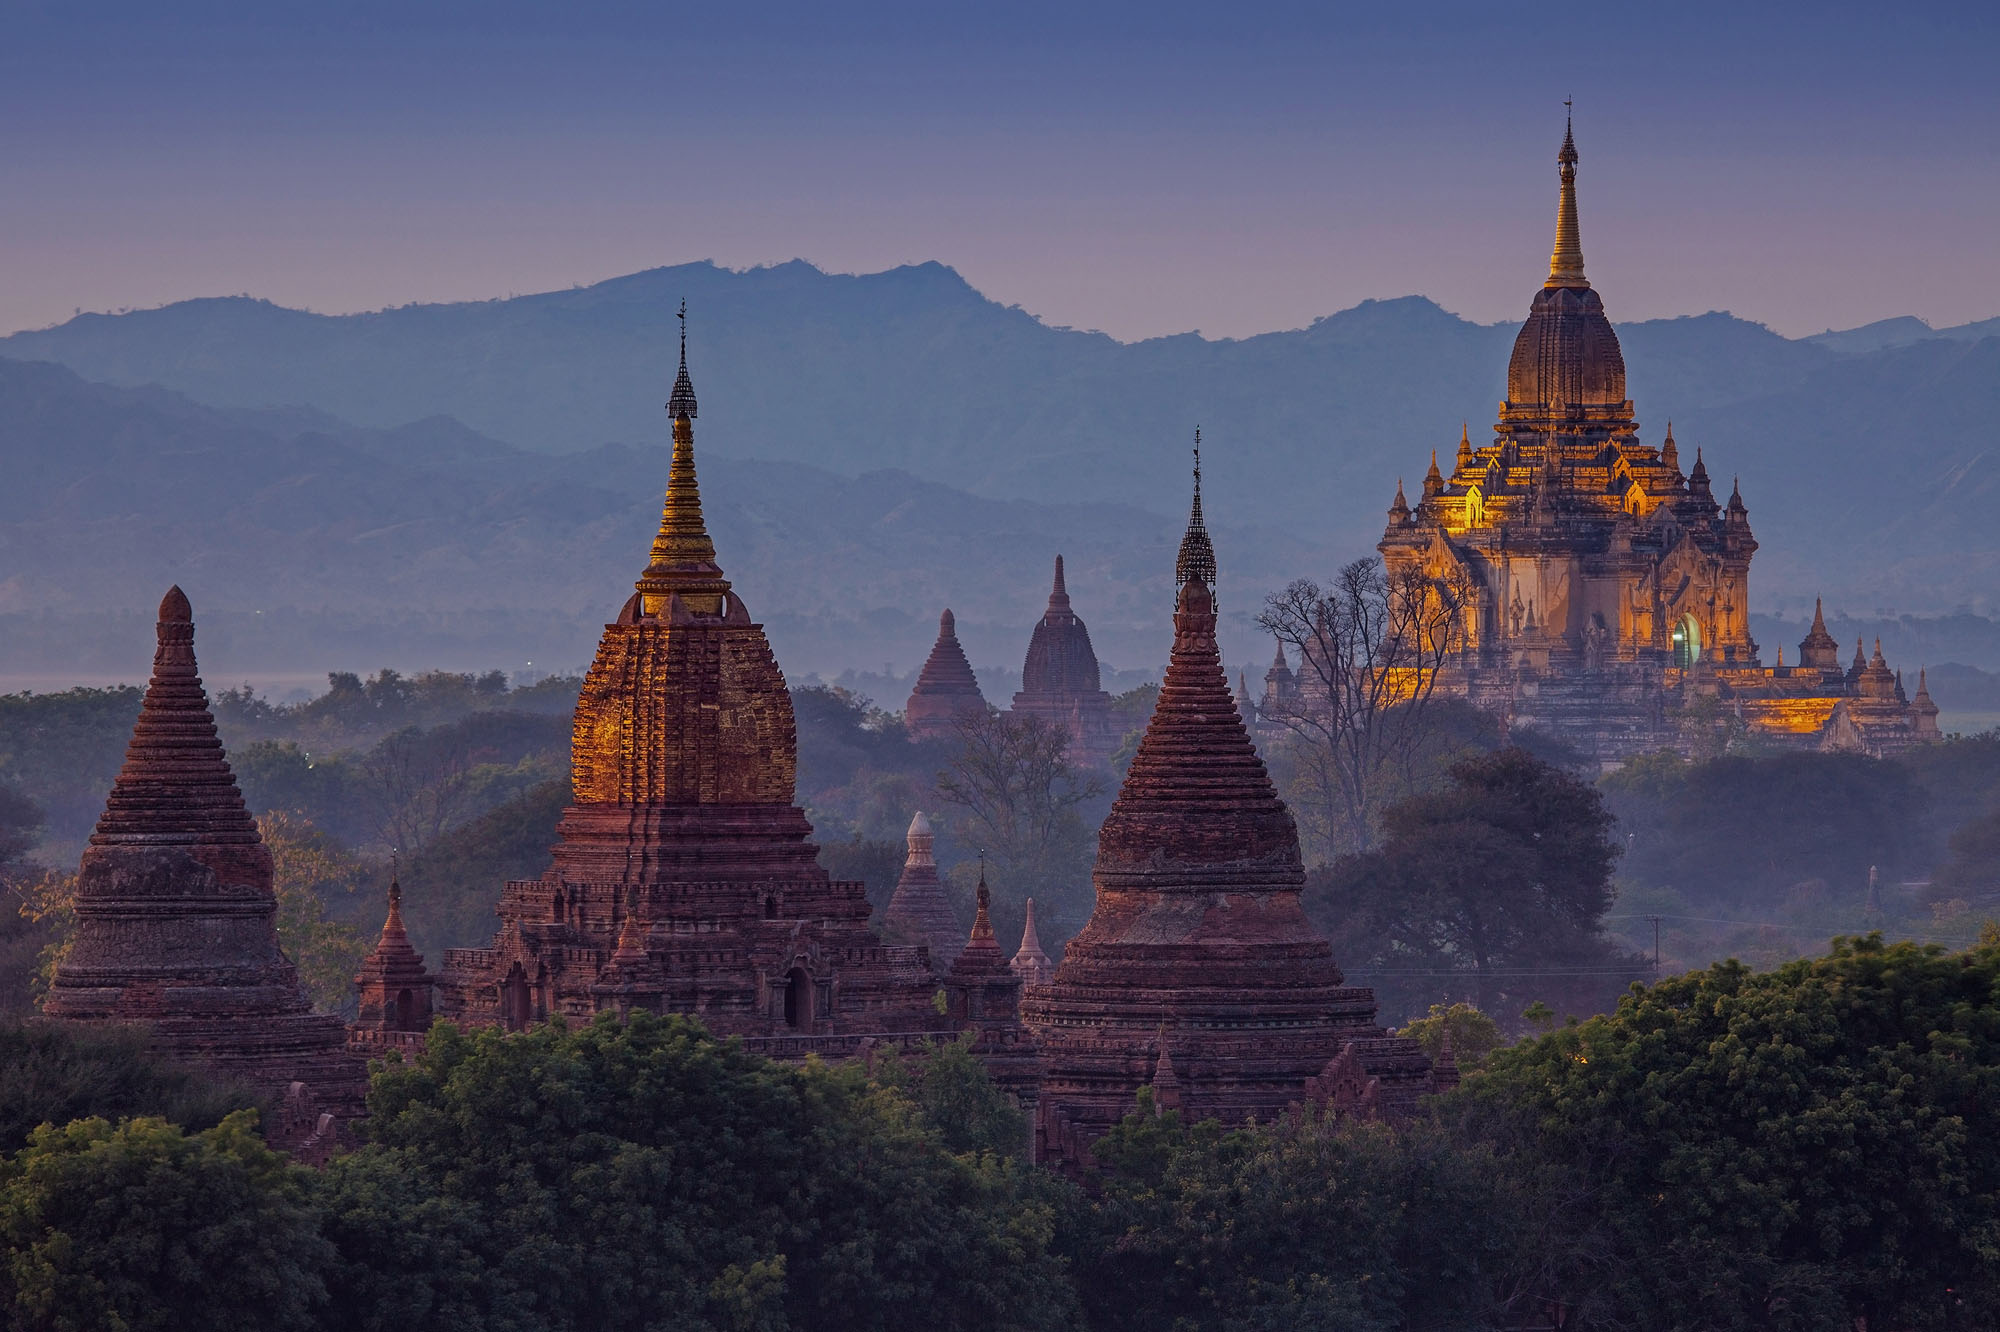What if one of these temples had a secret passageway leading to a hidden treasure? What might the treasure be? Imagine if, within the ancient walls of one of Bagan's majestic temples, a secret passageway lay hidden, known only to a few. This clandestine corridor would be concealed behind an intricately carved panel, seemingly indistinguishable from the other wall decorations. Once discovered and opened, the passageway would lead deep into the heart of the temple, through winding tunnels adorned with hidden inscriptions and sacred symbols that glow faintly under torchlight. At the end of this mysterious journey, one would find a forgotten chamber housing a treasure of unimaginable value – not of gold or gems, but ancient scrolls and scriptures. These documents, preserved for centuries, would unveil the lost teachings of revered monks, ancient celestial maps, and the philosophical musings of great thinkers from bygone eras. This intellectual and spiritual treasure trove would illuminate lost chapters of human history and wisdom, offering profound insights and answers to some of the world's most enduring mysteries. It would be a treasure that enriches the mind and spirit, far surpassing the value of any material wealth. 